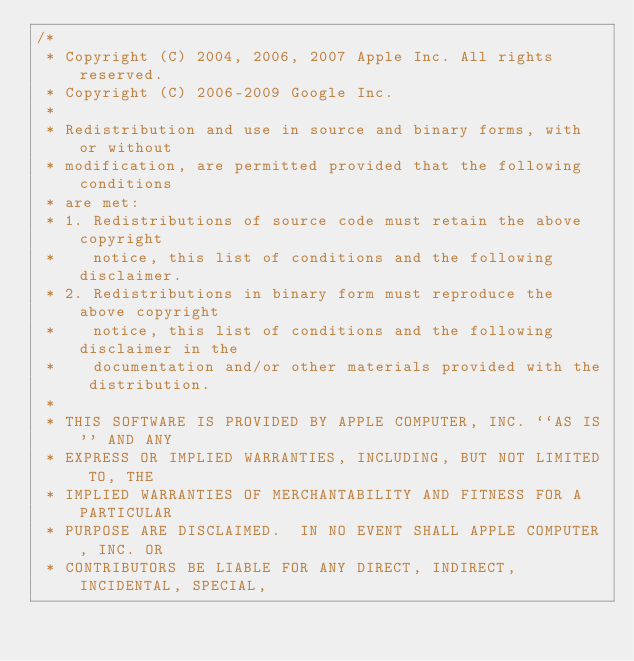Convert code to text. <code><loc_0><loc_0><loc_500><loc_500><_ObjectiveC_>/*
 * Copyright (C) 2004, 2006, 2007 Apple Inc. All rights reserved.
 * Copyright (C) 2006-2009 Google Inc.
 *
 * Redistribution and use in source and binary forms, with or without
 * modification, are permitted provided that the following conditions
 * are met:
 * 1. Redistributions of source code must retain the above copyright
 *    notice, this list of conditions and the following disclaimer.
 * 2. Redistributions in binary form must reproduce the above copyright
 *    notice, this list of conditions and the following disclaimer in the
 *    documentation and/or other materials provided with the distribution.
 *
 * THIS SOFTWARE IS PROVIDED BY APPLE COMPUTER, INC. ``AS IS'' AND ANY
 * EXPRESS OR IMPLIED WARRANTIES, INCLUDING, BUT NOT LIMITED TO, THE
 * IMPLIED WARRANTIES OF MERCHANTABILITY AND FITNESS FOR A PARTICULAR
 * PURPOSE ARE DISCLAIMED.  IN NO EVENT SHALL APPLE COMPUTER, INC. OR
 * CONTRIBUTORS BE LIABLE FOR ANY DIRECT, INDIRECT, INCIDENTAL, SPECIAL,</code> 